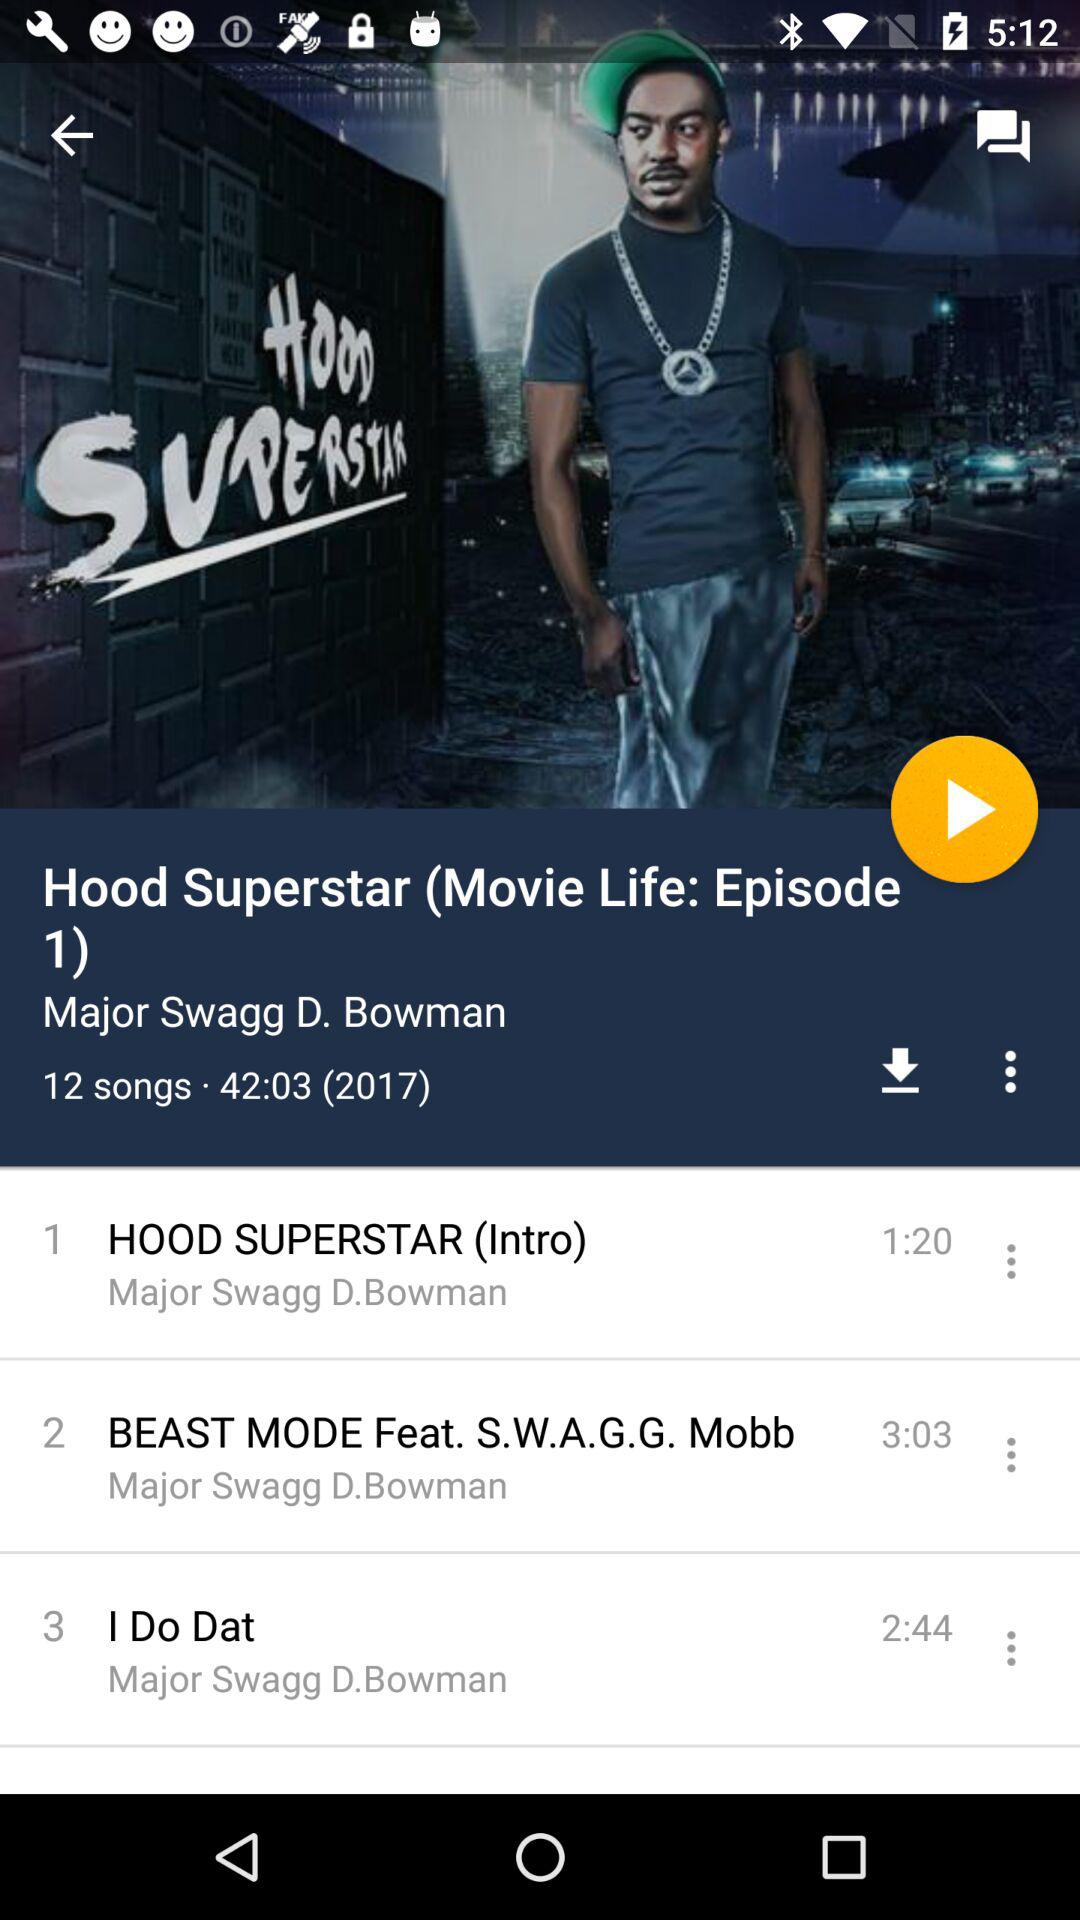How many songs are on the album?
Answer the question using a single word or phrase. 12 